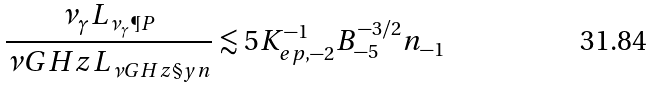<formula> <loc_0><loc_0><loc_500><loc_500>\frac { \nu _ { \gamma } L _ { \nu _ { \gamma } \P P } } { \nu G H z L _ { \nu G H z \S y n } } \lesssim 5 K _ { e p , - 2 } ^ { - 1 } B _ { - 5 } ^ { - 3 / 2 } n _ { - 1 }</formula> 